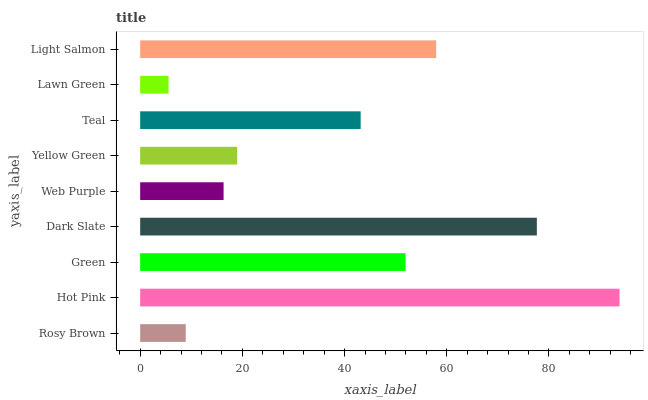Is Lawn Green the minimum?
Answer yes or no. Yes. Is Hot Pink the maximum?
Answer yes or no. Yes. Is Green the minimum?
Answer yes or no. No. Is Green the maximum?
Answer yes or no. No. Is Hot Pink greater than Green?
Answer yes or no. Yes. Is Green less than Hot Pink?
Answer yes or no. Yes. Is Green greater than Hot Pink?
Answer yes or no. No. Is Hot Pink less than Green?
Answer yes or no. No. Is Teal the high median?
Answer yes or no. Yes. Is Teal the low median?
Answer yes or no. Yes. Is Green the high median?
Answer yes or no. No. Is Dark Slate the low median?
Answer yes or no. No. 